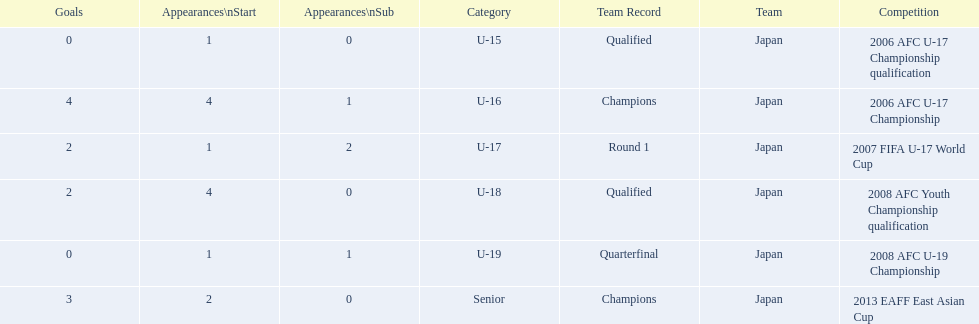What are all of the competitions? 2006 AFC U-17 Championship qualification, 2006 AFC U-17 Championship, 2007 FIFA U-17 World Cup, 2008 AFC Youth Championship qualification, 2008 AFC U-19 Championship, 2013 EAFF East Asian Cup. How many starting appearances were there? 1, 4, 1, 4, 1, 2. What about just during 2013 eaff east asian cup and 2007 fifa u-17 world cup? 1, 2. Which of those had more starting appearances? 2013 EAFF East Asian Cup. 